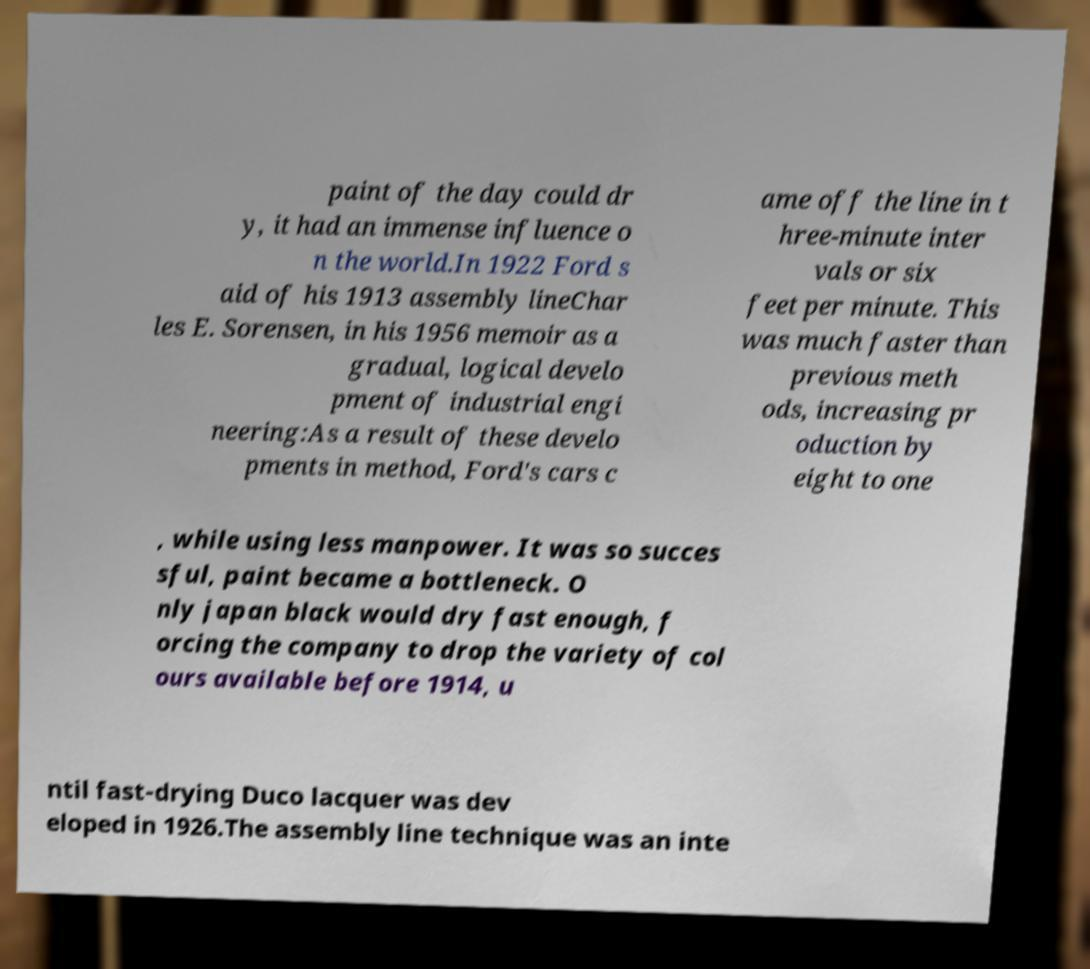What messages or text are displayed in this image? I need them in a readable, typed format. paint of the day could dr y, it had an immense influence o n the world.In 1922 Ford s aid of his 1913 assembly lineChar les E. Sorensen, in his 1956 memoir as a gradual, logical develo pment of industrial engi neering:As a result of these develo pments in method, Ford's cars c ame off the line in t hree-minute inter vals or six feet per minute. This was much faster than previous meth ods, increasing pr oduction by eight to one , while using less manpower. It was so succes sful, paint became a bottleneck. O nly japan black would dry fast enough, f orcing the company to drop the variety of col ours available before 1914, u ntil fast-drying Duco lacquer was dev eloped in 1926.The assembly line technique was an inte 